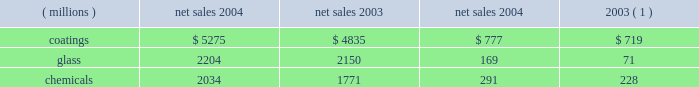Management 2019s discussion and analysis interest expense was $ 17 million less in 2004 than in 2003 reflecting the year over year reduction in debt of $ 316 million .
Other charges declined $ 30 million in 2004 due to a combination of lower environmental remediation , legal and workers compensation expenses and the absence of certain 2003 charges .
Other earnings were $ 28 million higher in 2004 due primarily to higher earnings from our equity affiliates .
The effective tax rate for 2004 was 30.29% ( 30.29 % ) compared to 34.76% ( 34.76 % ) for the full year 2003 .
The reduction in the rate for 2004 reflects the benefit of the subsidy offered pursuant to the medicare act not being subject to tax , the continued improvement in the geographical mix of non- u.s .
Earnings and the favorable resolution during 2004 of matters related to two open u.s .
Federal income tax years .
Net income in 2004 totaled $ 683 million , an increase of $ 189 million over 2003 , and earnings per share 2013 diluted increased $ 1.06 to $ 3.95 per share .
Results of business segments net sales operating income ( millions ) 2004 2003 2004 2003 ( 1 ) coatings $ 5275 $ 4835 $ 777 $ 719 .
Chemicals 2034 1771 291 228 ( 1 ) operating income by segment for 2003 has been revised to reflect a change in the allocation method for certain pension and other postretirement benefit costs in 2004 ( see note 22 , 201cbusiness segment information 201d , under item 8 of this form 10-k ) .
Coatings sales increased $ 440 million or 9% ( 9 % ) in 2004 .
Sales increased 6% ( 6 % ) from improved volumes across all our coatings businesses and 4% ( 4 % ) due to the positive effects of foreign currency translation , primarily from our european operations .
Sales declined 1% ( 1 % ) due to lower selling prices , principally in our automotive business .
Operating income increased $ 58 million in 2004 .
Factors increasing operating income were the higher sales volume ( $ 135 million ) and the favorable effects of currency translation described above and improved manufacturing efficiencies of $ 20 million .
Factors decreasing operating income were inflationary cost increases of $ 82 million and lower selling prices .
Glass sales increased $ 54 million or 3% ( 3 % ) in 2004 .
Sales increased 6% ( 6 % ) from improved volumes primarily from our performance glazings ( flat glass ) , fiber glass , and automotive original equipment businesses net of lower volumes in our automotive replacement glass business .
Sales also increased 2% ( 2 % ) due to the positive effects of foreign currency translation , primarily from our european fiber glass operations .
Sales declined 5% ( 5 % ) due to lower selling prices across all our glass businesses .
Operating income in 2004 increased $ 98 million .
Factors increasing operating income were improved manufacturing efficiencies of $ 110 million , higher sales volume ( $ 53 million ) described above , higher equity earnings and the gains on the sale/leaseback of precious metals of $ 19 million .
The principal factor decreasing operating income was lower selling prices .
Fiber glass volumes were up 15% ( 15 % ) for the year , although pricing declined .
With the shift of electronic printed wiring board production to asia and the volume and pricing gains there , equity earnings from our joint venture serving that region grew in 2004 .
These factors combined with focused cost reductions and manufacturing efficiencies to improve the operating performance of this business , as we continue to position it for future growth in profitability .
Chemicals sales increased $ 263 million or 15% ( 15 % ) in 2004 .
Sales increased 10% ( 10 % ) from improved volumes in our commodity and specialty businesses and 4% ( 4 % ) due to higher selling prices for our commodity products .
Sales also increased 1% ( 1 % ) due to the positive effects of foreign currency translation , primarily from our european operations .
Operating income increased $ 63 million in 2004 .
Factors increasing operating income were the higher selling prices for our commodity products and the higher sales volume ( $ 73 million ) described above , improved manufacturing efficiencies of $ 25 million and lower environmental expenses .
Factors decreasing 2004 operating income were inflationary cost increases of $ 40 million and higher energy costs of $ 79 million .
Other significant factors the company 2019s pension and other postretirement benefit costs for 2004 were $ 45 million lower than in 2003 .
This decrease reflects the market driven growth in pension plan assets that occurred in 2003 , the impact of the $ 140 million in cash contributed to the pension plans by the company in 2004 and the benefit of the subsidy offered pursuant to the medicare act , as discussed in note 12 , 201cpension and other postretirement benefits , 201d under item 8 of this form 10-k .
Commitments and contingent liabilities , including environmental matters ppg is involved in a number of lawsuits and claims , both actual and potential , including some that it has asserted against others , in which substantial monetary damages are sought .
See item 3 , 201clegal proceedings 201d of this form 10-k and note 13 , 201ccommitments and contingent liabilities , 201d under item 8 of this form 10-k for a description of certain of these lawsuits , including a description of the proposed ppg settlement arrangement for asbestos claims announced on may 14 , 2002 .
As discussed in item 3 and note 13 , although the result of any future litigation of such lawsuits and claims is inherently unpredictable , management believes that , in the aggregate , the outcome of all lawsuits and claims involving ppg , including asbestos-related claims in the event the ppg settlement arrangement described in note 13 does not become effective , will not have a material effect on ppg 2019s consolidated financial position or liquidity ; however , any such outcome may be material to the results of operations of any particular period in which costs , if any , are recognized .
The company has been named as a defendant , along with various other co-defendants , in a number of antitrust lawsuits filed in federal and state courts .
These suits allege that ppg acted with competitors to fix prices and allocate markets in the flat glass and automotive refinish industries .
22 2005 ppg annual report and form 10-k .
What is operating income return on sales for 2003 in the coatings segment? 
Computations: (719 / 4835)
Answer: 0.14871. 